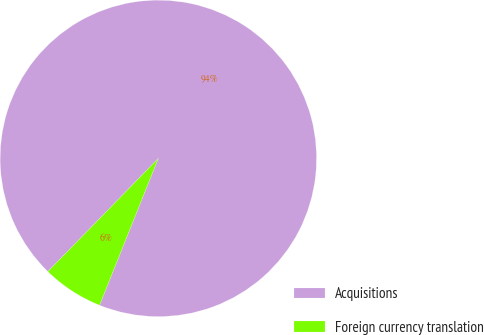Convert chart. <chart><loc_0><loc_0><loc_500><loc_500><pie_chart><fcel>Acquisitions<fcel>Foreign currency translation<nl><fcel>93.75%<fcel>6.25%<nl></chart> 